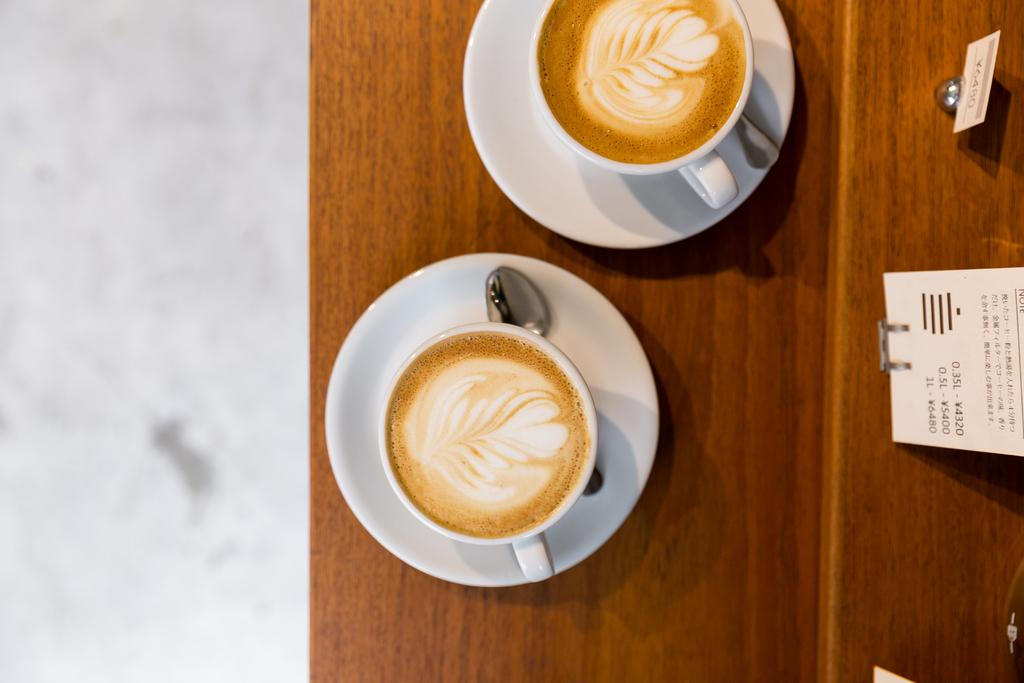What is the main object in the center of the image? There is a table in the center of the image. What is inside the cups on the table? The cups on the table contain coffee. What accompanies the cups on the table? There are saucers and spoons on the table. What else can be seen in the image besides the table and its contents? There are boards visible in the image. What type of scarf is draped over the coffee cups in the image? There is no scarf present in the image; it only features cups containing coffee, saucers, spoons, and boards. 